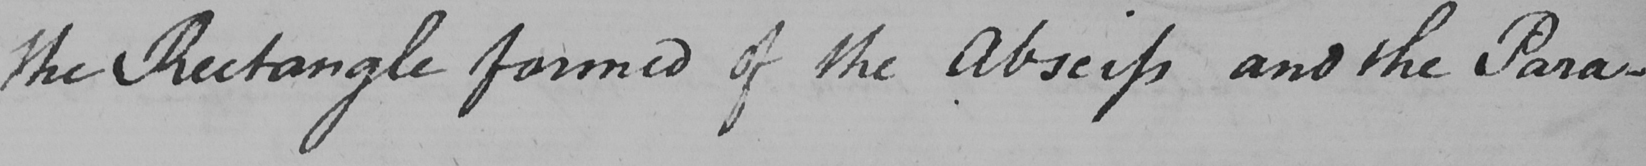What does this handwritten line say? the Rectangle formed of the Abseiss and the Para- 